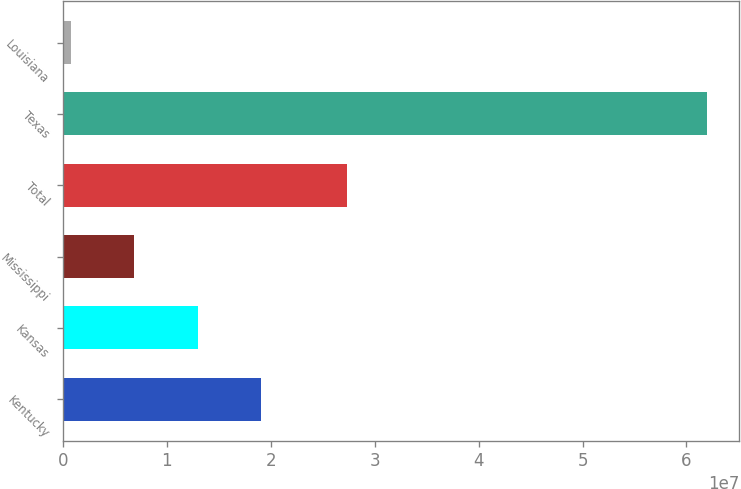Convert chart. <chart><loc_0><loc_0><loc_500><loc_500><bar_chart><fcel>Kentucky<fcel>Kansas<fcel>Mississippi<fcel>Total<fcel>Texas<fcel>Louisiana<nl><fcel>1.91062e+07<fcel>1.2984e+07<fcel>6.86176e+06<fcel>2.73334e+07<fcel>6.19616e+07<fcel>739556<nl></chart> 